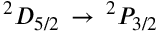<formula> <loc_0><loc_0><loc_500><loc_500>^ { 2 } D _ { 5 / 2 } \, \rightarrow \, ^ { 2 } P _ { 3 / 2 }</formula> 